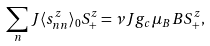Convert formula to latex. <formula><loc_0><loc_0><loc_500><loc_500>\sum _ { n } J \langle s _ { n n } ^ { z } \rangle _ { 0 } S ^ { z } _ { + } = \nu J g _ { c } \mu _ { B } B S ^ { z } _ { + } ,</formula> 